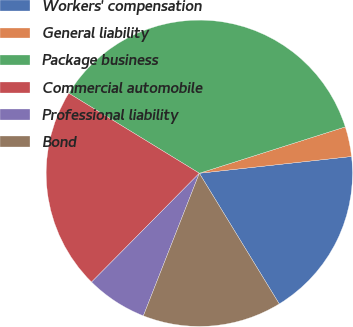Convert chart to OTSL. <chart><loc_0><loc_0><loc_500><loc_500><pie_chart><fcel>Workers' compensation<fcel>General liability<fcel>Package business<fcel>Commercial automobile<fcel>Professional liability<fcel>Bond<nl><fcel>18.01%<fcel>3.15%<fcel>36.35%<fcel>21.33%<fcel>6.47%<fcel>14.69%<nl></chart> 